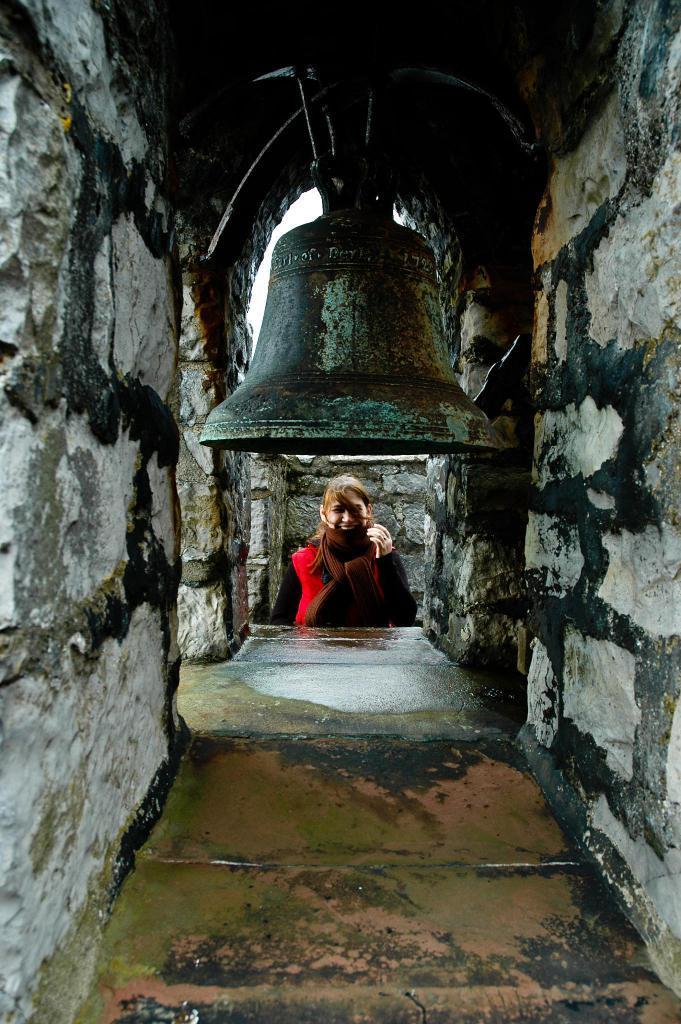Please provide a concise description of this image. In this image there is a bell attached to the roof. Behind the floor there is a person. Behind her there is a wall. Behind the bell there is sky. There is a wall having an entrance. 